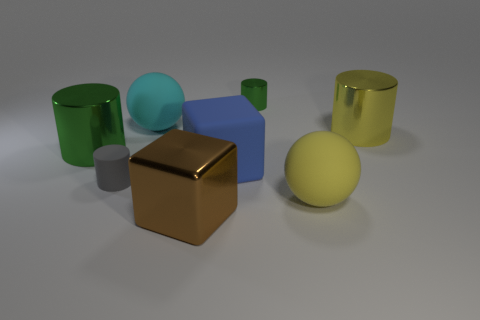Add 2 large green shiny cylinders. How many objects exist? 10 Subtract all yellow cylinders. How many cylinders are left? 3 Subtract all cubes. How many objects are left? 6 Subtract 4 cylinders. How many cylinders are left? 0 Subtract all green cylinders. How many cylinders are left? 2 Add 7 large yellow things. How many large yellow things exist? 9 Subtract 1 yellow spheres. How many objects are left? 7 Subtract all green spheres. Subtract all purple blocks. How many spheres are left? 2 Subtract all gray balls. How many green cylinders are left? 2 Subtract all large green cubes. Subtract all big yellow matte spheres. How many objects are left? 7 